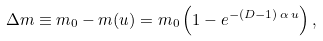<formula> <loc_0><loc_0><loc_500><loc_500>\Delta m \equiv m _ { 0 } - m ( u ) = m _ { 0 } \left ( 1 - e ^ { - ( D - 1 ) \, \alpha \, u } \right ) ,</formula> 